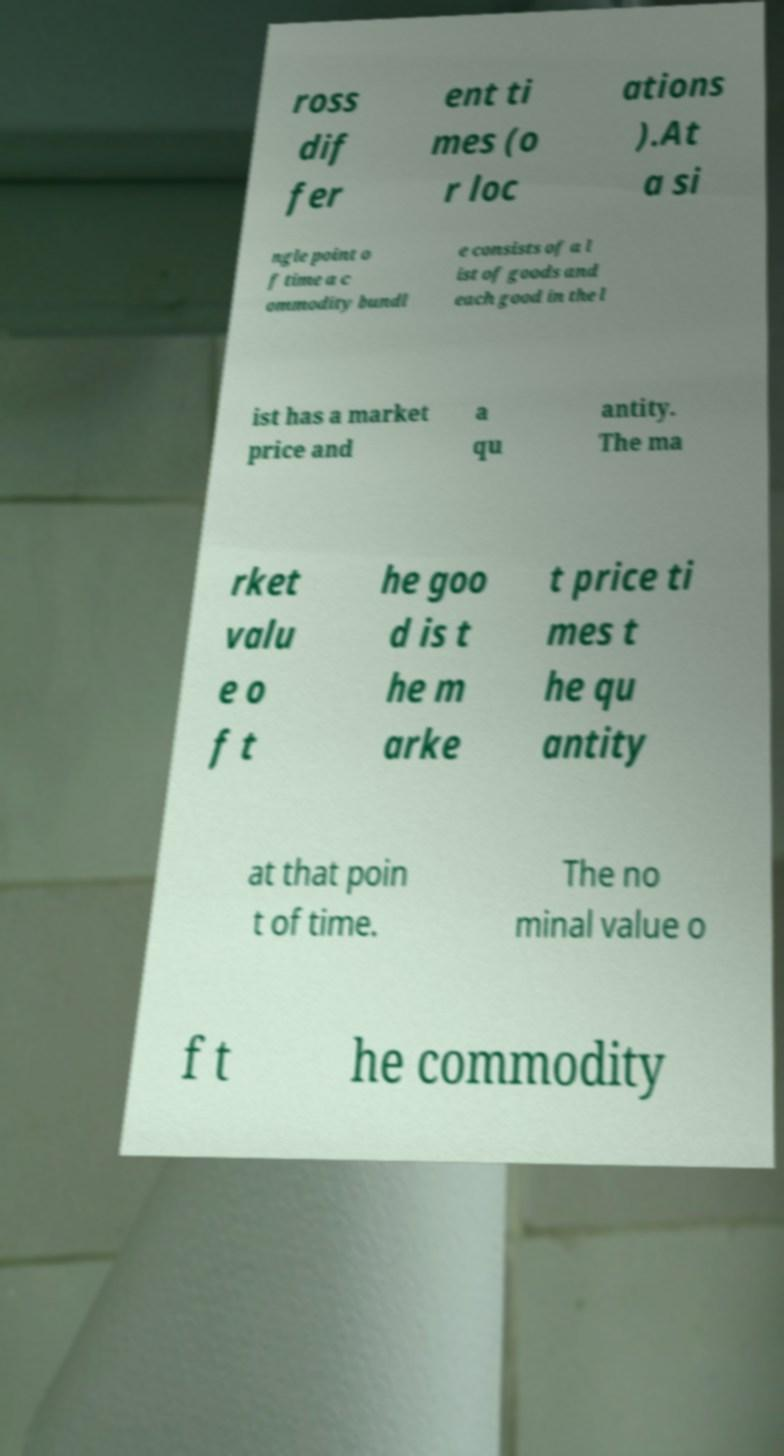Could you extract and type out the text from this image? ross dif fer ent ti mes (o r loc ations ).At a si ngle point o f time a c ommodity bundl e consists of a l ist of goods and each good in the l ist has a market price and a qu antity. The ma rket valu e o f t he goo d is t he m arke t price ti mes t he qu antity at that poin t of time. The no minal value o f t he commodity 